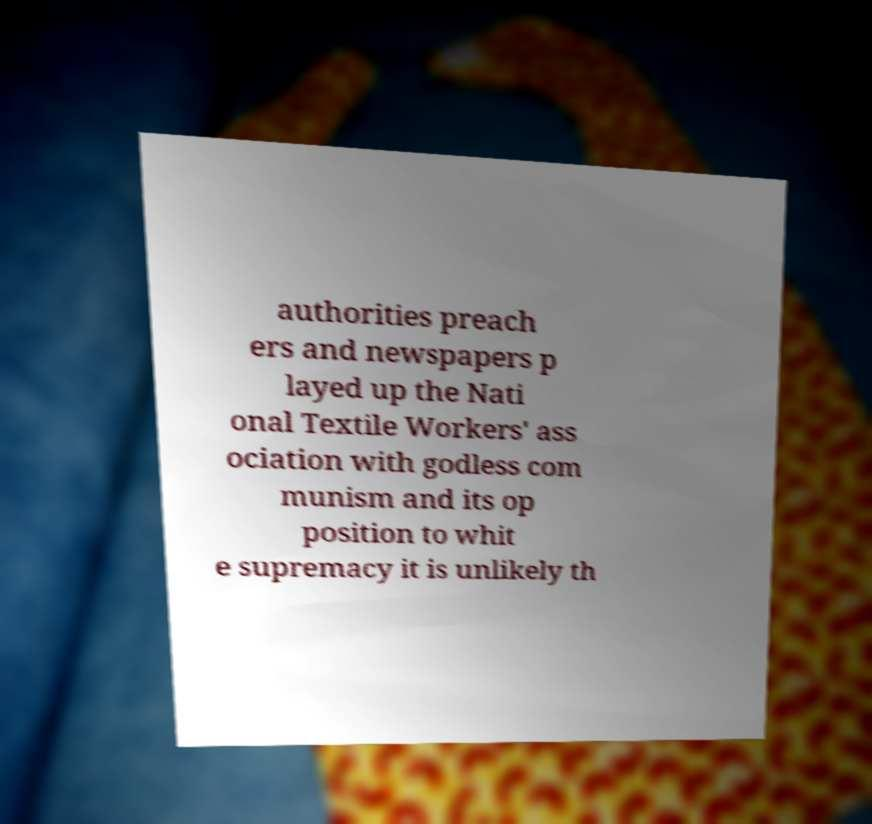For documentation purposes, I need the text within this image transcribed. Could you provide that? authorities preach ers and newspapers p layed up the Nati onal Textile Workers' ass ociation with godless com munism and its op position to whit e supremacy it is unlikely th 